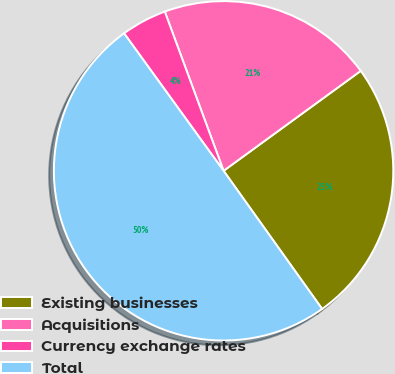Convert chart. <chart><loc_0><loc_0><loc_500><loc_500><pie_chart><fcel>Existing businesses<fcel>Acquisitions<fcel>Currency exchange rates<fcel>Total<nl><fcel>25.16%<fcel>20.61%<fcel>4.34%<fcel>49.89%<nl></chart> 